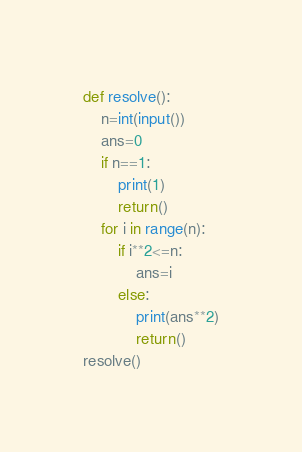Convert code to text. <code><loc_0><loc_0><loc_500><loc_500><_Python_>def resolve():
    n=int(input())
    ans=0
    if n==1:
        print(1)
        return()
    for i in range(n):
        if i**2<=n:
            ans=i
        else:
            print(ans**2)
            return()
resolve()</code> 